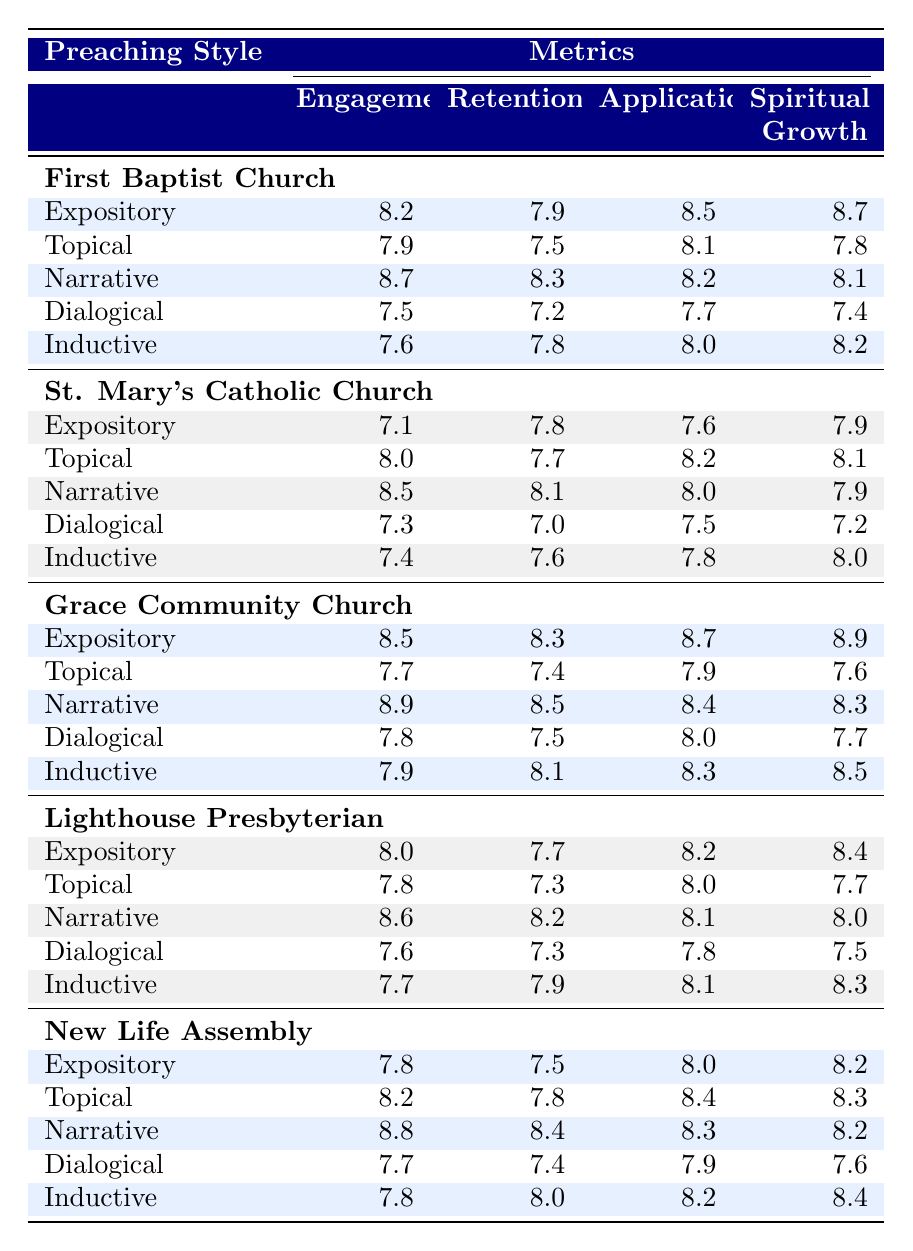What preaching style had the highest engagement score at Grace Community Church? The engagement scores for Grace Community Church are Expository (8.5), Topical (7.7), Narrative (8.9), Dialogical (7.8), and Inductive (7.9). The highest score is 8.9 from the Narrative style.
Answer: Narrative Which congregation had the lowest retention score using the Dialogical preaching style? The retention scores for the Dialogical style are: First Baptist Church (7.2), St. Mary's Catholic Church (7.0), Grace Community Church (7.5), Lighthouse Presbyterian (7.3), and New Life Assembly (7.4). The lowest score is 7.0 from St. Mary's Catholic Church.
Answer: St. Mary's Catholic Church What is the average application score across all preaching styles for First Baptist Church? The application scores for First Baptist Church are Expository (8.5), Topical (8.1), Narrative (8.2), Dialogical (7.7), and Inductive (8.0). The average is (8.5 + 8.1 + 8.2 + 7.7 + 8.0) / 5 = 8.1.
Answer: 8.1 Which preaching style had the highest average spiritual growth score across all congregations? The spiritual growth scores for each style are: Expository (8.2), Topical (8.1), Narrative (8.3), Dialogical (7.5), and Inductive (8.4). Summing these and averaging gives: (8.2 + 8.1 + 8.3 + 7.5 + 8.4) / 5 = 8.1. The highest average spiritual growth score is 8.4 from the Inductive style.
Answer: Inductive Did New Life Assembly show better engagement with Narrative preaching compared to Expository preaching? The engagement scores are: Narrative (8.8) and Expository (7.8) for New Life Assembly. Comparison shows that Narrative (8.8) is higher than Expository (7.8), thus New Life Assembly did show better engagement with Narrative preaching.
Answer: Yes Which congregation had the highest overall spiritual growth score with the Expository preaching style? The spiritual growth scores for Expository preaching are: First Baptist Church (8.7), St. Mary's Catholic Church (7.9), Grace Community Church (8.9), Lighthouse Presbyterian (8.4), and New Life Assembly (8.2). The highest score is 8.9 from Grace Community Church.
Answer: Grace Community Church What is the difference between the highest and lowest application scores for the Topical style across congregations? The application scores for Topical preaching are: First Baptist Church (8.1), St. Mary's Catholic Church (8.2), Grace Community Church (7.9), Lighthouse Presbyterian (8.0), and New Life Assembly (8.4). The highest is 8.4 from New Life Assembly, and the lowest is 7.7 from Grace Community Church, giving a difference of 8.4 - 7.7 = 0.7.
Answer: 0.7 Which style had the most consistent scores (smallest range) in retention across all congregations? The retention scores by style are: Expository (7.2 to 8.3), Topical (7.3 to 8.0), Narrative (8.1 to 8.9), Dialogical (7.0 to 7.8), and Inductive (7.6 to 8.1). The range (highest – lowest) is smallest for the Dialogical style (7.0 to 7.8 = 0.8).
Answer: Dialogical Which preaching style showed a decline in engagement from First Baptist Church to Grace Community Church? The engagement scores for First Baptist Church and Grace Community Church for each style are compared: Expository (8.2 to 8.5), Topical (7.9 to 7.7), Narrative (8.7 to 8.9), Dialogical (7.5 to 7.8), Inductive (7.6 to 7.9). The Topical style shows a decline from 7.9 to 7.7, indicating a decrease.
Answer: Topical 